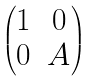Convert formula to latex. <formula><loc_0><loc_0><loc_500><loc_500>\begin{pmatrix} 1 & 0 \\ 0 & A \end{pmatrix}</formula> 